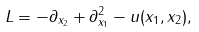Convert formula to latex. <formula><loc_0><loc_0><loc_500><loc_500>L = - \partial _ { x _ { 2 } } + \partial _ { x _ { 1 } } ^ { 2 } - u ( x _ { 1 } , x _ { 2 } ) ,</formula> 